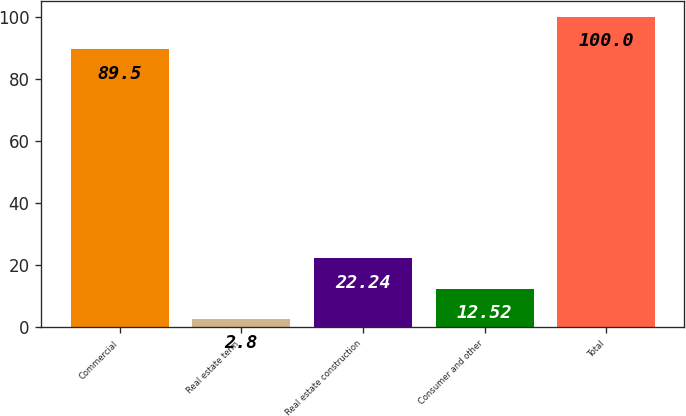Convert chart. <chart><loc_0><loc_0><loc_500><loc_500><bar_chart><fcel>Commercial<fcel>Real estate term<fcel>Real estate construction<fcel>Consumer and other<fcel>Total<nl><fcel>89.5<fcel>2.8<fcel>22.24<fcel>12.52<fcel>100<nl></chart> 